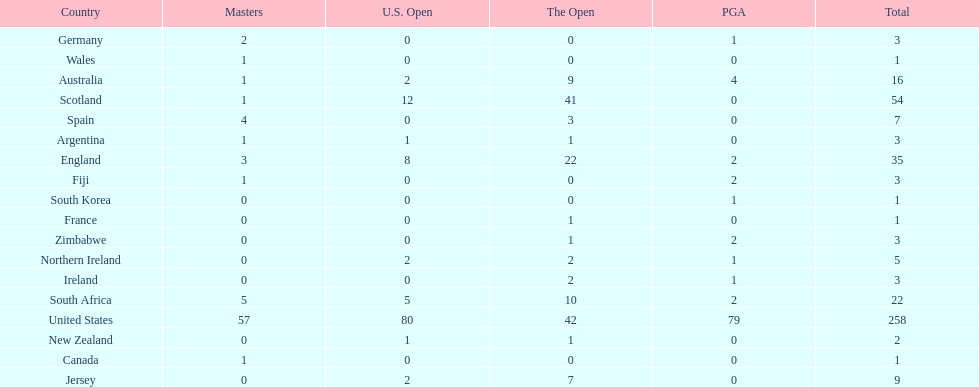Which of the countries listed are african? South Africa, Zimbabwe. Which of those has the least championship winning golfers? Zimbabwe. 